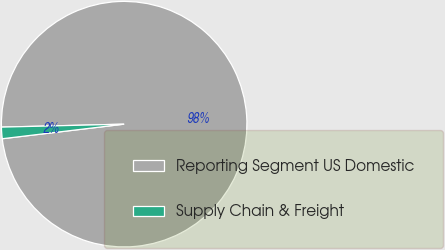Convert chart to OTSL. <chart><loc_0><loc_0><loc_500><loc_500><pie_chart><fcel>Reporting Segment US Domestic<fcel>Supply Chain & Freight<nl><fcel>98.49%<fcel>1.51%<nl></chart> 